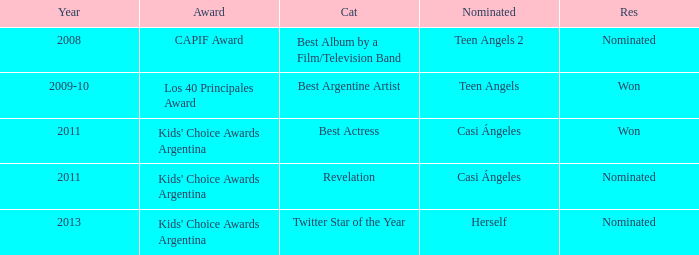What year saw an award in the category of Revelation? 2011.0. 